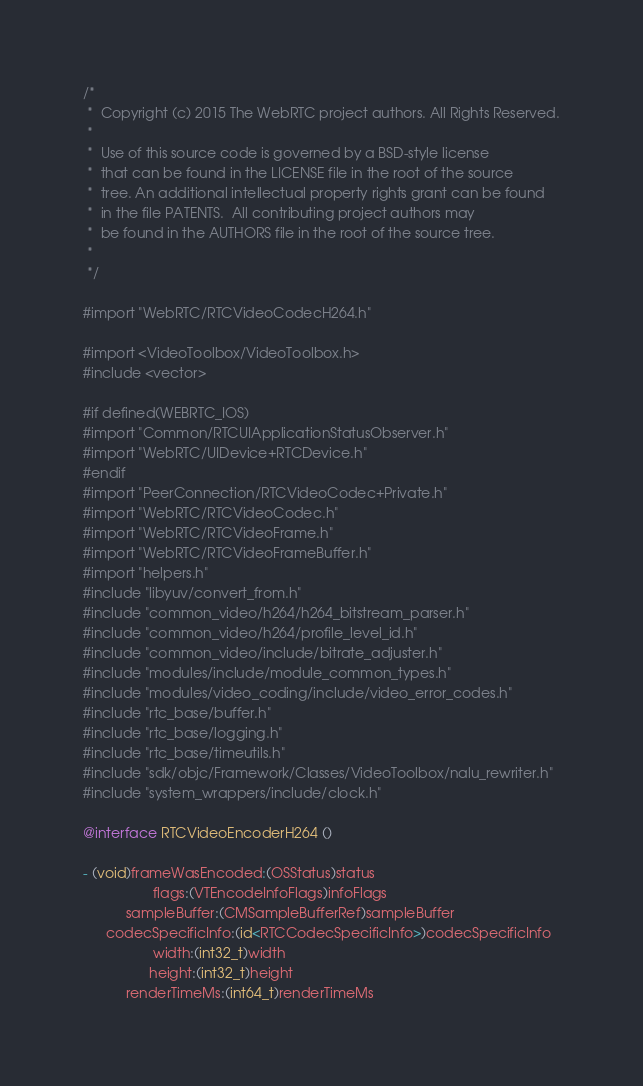<code> <loc_0><loc_0><loc_500><loc_500><_ObjectiveC_>/*
 *  Copyright (c) 2015 The WebRTC project authors. All Rights Reserved.
 *
 *  Use of this source code is governed by a BSD-style license
 *  that can be found in the LICENSE file in the root of the source
 *  tree. An additional intellectual property rights grant can be found
 *  in the file PATENTS.  All contributing project authors may
 *  be found in the AUTHORS file in the root of the source tree.
 *
 */

#import "WebRTC/RTCVideoCodecH264.h"

#import <VideoToolbox/VideoToolbox.h>
#include <vector>

#if defined(WEBRTC_IOS)
#import "Common/RTCUIApplicationStatusObserver.h"
#import "WebRTC/UIDevice+RTCDevice.h"
#endif
#import "PeerConnection/RTCVideoCodec+Private.h"
#import "WebRTC/RTCVideoCodec.h"
#import "WebRTC/RTCVideoFrame.h"
#import "WebRTC/RTCVideoFrameBuffer.h"
#import "helpers.h"
#include "libyuv/convert_from.h"
#include "common_video/h264/h264_bitstream_parser.h"
#include "common_video/h264/profile_level_id.h"
#include "common_video/include/bitrate_adjuster.h"
#include "modules/include/module_common_types.h"
#include "modules/video_coding/include/video_error_codes.h"
#include "rtc_base/buffer.h"
#include "rtc_base/logging.h"
#include "rtc_base/timeutils.h"
#include "sdk/objc/Framework/Classes/VideoToolbox/nalu_rewriter.h"
#include "system_wrappers/include/clock.h"

@interface RTCVideoEncoderH264 ()

- (void)frameWasEncoded:(OSStatus)status
                  flags:(VTEncodeInfoFlags)infoFlags
           sampleBuffer:(CMSampleBufferRef)sampleBuffer
      codecSpecificInfo:(id<RTCCodecSpecificInfo>)codecSpecificInfo
                  width:(int32_t)width
                 height:(int32_t)height
           renderTimeMs:(int64_t)renderTimeMs</code> 